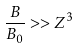Convert formula to latex. <formula><loc_0><loc_0><loc_500><loc_500>\frac { B } { B _ { 0 } } > > Z ^ { 3 }</formula> 